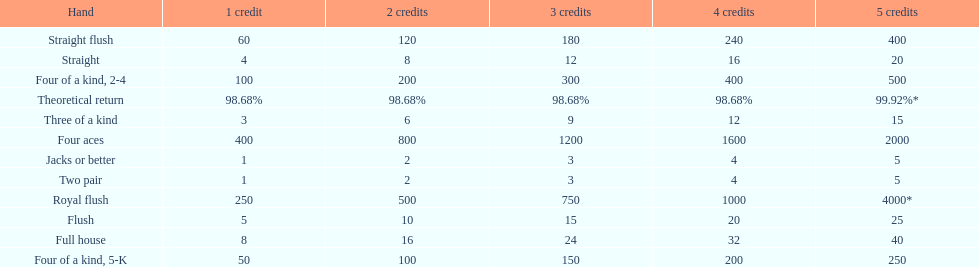Is a 2 credit full house the same as a 5 credit three of a kind? No. 